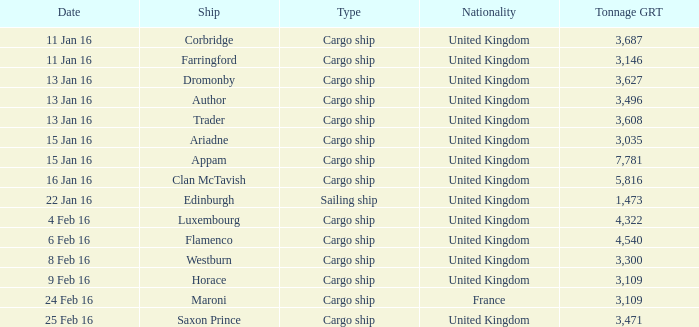What is the most tonnage grt of any ship sunk or captured on 16 jan 16? 5816.0. 